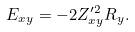<formula> <loc_0><loc_0><loc_500><loc_500>E _ { x y } = - 2 Z _ { x y } ^ { \prime 2 } R _ { y } .</formula> 